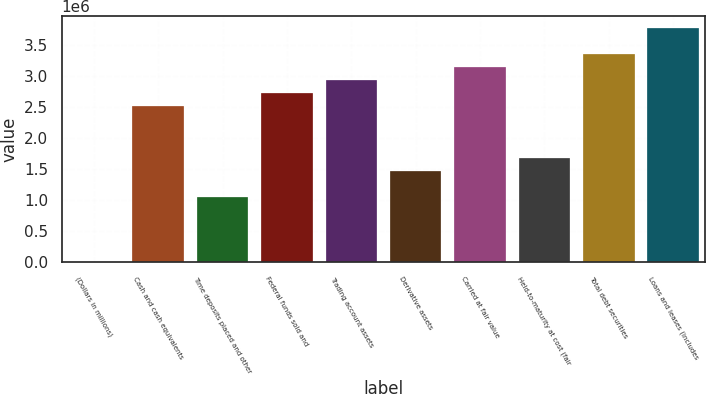<chart> <loc_0><loc_0><loc_500><loc_500><bar_chart><fcel>(Dollars in millions)<fcel>Cash and cash equivalents<fcel>Time deposits placed and other<fcel>Federal funds sold and<fcel>Trading account assets<fcel>Derivative assets<fcel>Carried at fair value<fcel>Held-to-maturity at cost (fair<fcel>Total debt securities<fcel>Loans and leases (includes<nl><fcel>2013<fcel>2.52232e+06<fcel>1.05214e+06<fcel>2.73235e+06<fcel>2.94238e+06<fcel>1.4722e+06<fcel>3.1524e+06<fcel>1.68222e+06<fcel>3.36243e+06<fcel>3.78248e+06<nl></chart> 